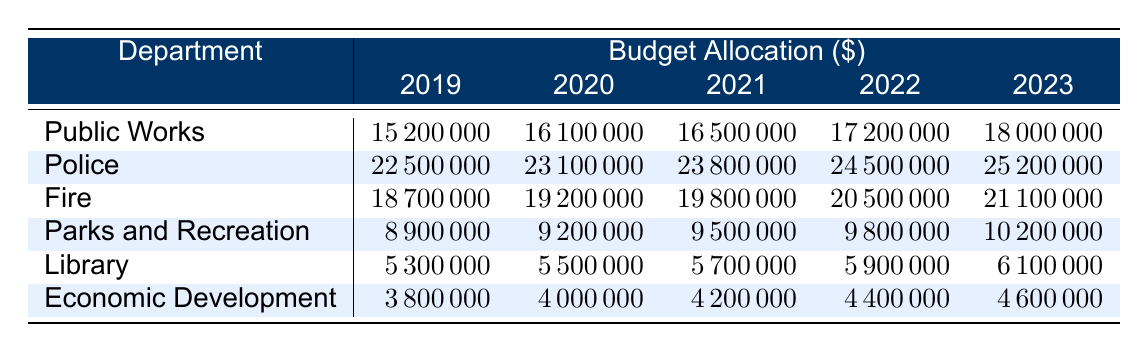What was the budget allocation for the Police in 2021? The table shows the budget allocation for the Police department in 2021 as 23800000.
Answer: 23800000 Which department received the highest budget in 2023? Looking at the 2023 column, the Police department has the highest budget allocation of 25200000.
Answer: Police What is the total budget allocation for Fire from 2019 to 2023? To find the total for Fire, we sum the values from 2019 to 2023: 18700000 + 19200000 + 19800000 + 20500000 + 21100000 = 109600000.
Answer: 109600000 Did the budget allocation for Public Works increase every year? By examining the Public Works row, we can see that the budget increases from year to year without any decreases.
Answer: Yes What is the percentage increase in budget allocation for the Parks and Recreation department from 2019 to 2023? The budget for Parks and Recreation in 2019 is 8900000 and in 2023 is 10200000. The increase is 10200000 - 8900000 = 1300000. To find the percentage increase, (1300000 / 8900000) * 100 = approximately 14.6%.
Answer: 14.6% Which department had the lowest budget allocation in 2022? Checking the 2022 column, Economic Development has a budget allocation of 4400000, which is the lowest among all departments.
Answer: Economic Development What is the average budget allocation for the Library over the five years? To find the average, we sum the values for the Library: 5300000 + 5500000 + 5700000 + 5900000 + 6100000 = 30000000. Then, we divide by 5, resulting in 30000000 / 5 = 6000000.
Answer: 6000000 Was there any year when the budget allocation for the Economic Development department was above 4500000? By looking at the Economic Development row, we see that all values are below 4600000, which means that it was never above 4500000.
Answer: No If we compare the allocation for Police and Fire in 2023, how much more did the Police receive? The allocation for Police in 2023 is 25200000 and for Fire it is 21100000. The difference is 25200000 - 21100000 = 4100000.
Answer: 4100000 Which department had the smallest budget in 2019? In the 2019 column, the Economic Development department shows a budget allocation of 3800000, the smallest among all departments.
Answer: Economic Development 